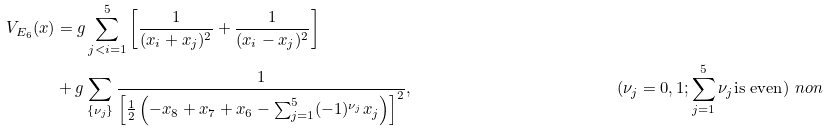<formula> <loc_0><loc_0><loc_500><loc_500>V _ { E _ { 6 } } ( x ) & = g \sum _ { j < i = 1 } ^ { 5 } \left [ \frac { 1 } { ( x _ { i } + x _ { j } ) ^ { 2 } } + \frac { 1 } { ( x _ { i } - x _ { j } ) ^ { 2 } } \right ] \\ & + g \sum _ { \{ \nu _ { j } \} } \frac { 1 } { \left [ \frac { 1 } { 2 } \left ( { - x _ { 8 } + x _ { 7 } + x _ { 6 } - \sum _ { j = 1 } ^ { 5 } ( - 1 ) ^ { \nu _ { j } } x _ { j } } \right ) \right ] ^ { 2 } } , \ & ( \nu _ { j } = 0 , 1 ; \sum _ { j = 1 } ^ { 5 } \nu _ { j } \text {is even} ) \ n o n</formula> 